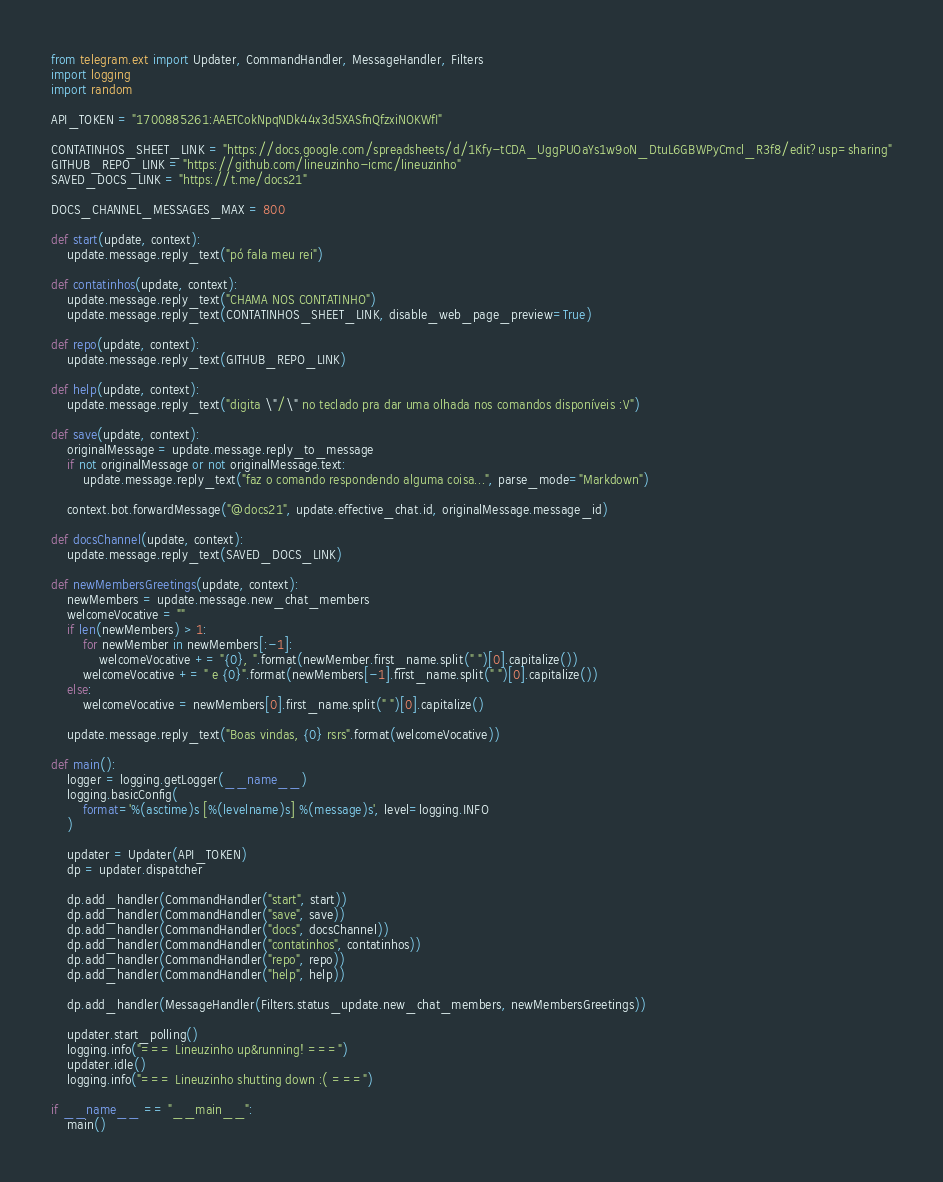<code> <loc_0><loc_0><loc_500><loc_500><_Python_>from telegram.ext import Updater, CommandHandler, MessageHandler, Filters
import logging
import random

API_TOKEN = "1700885261:AAETCokNpqNDk44x3d5XASfnQfzxiNOKWfI"

CONTATINHOS_SHEET_LINK = "https://docs.google.com/spreadsheets/d/1Kfy-tCDA_UggPUOaYs1w9oN_DtuL6GBWPyCmcl_R3f8/edit?usp=sharing"
GITHUB_REPO_LINK = "https://github.com/lineuzinho-icmc/lineuzinho"
SAVED_DOCS_LINK = "https://t.me/docs21"

DOCS_CHANNEL_MESSAGES_MAX = 800

def start(update, context):
    update.message.reply_text("pó fala meu rei")

def contatinhos(update, context):
    update.message.reply_text("CHAMA NOS CONTATINHO")
    update.message.reply_text(CONTATINHOS_SHEET_LINK, disable_web_page_preview=True)

def repo(update, context):
    update.message.reply_text(GITHUB_REPO_LINK)

def help(update, context):
    update.message.reply_text("digita \"/\" no teclado pra dar uma olhada nos comandos disponíveis :V")

def save(update, context):
    originalMessage = update.message.reply_to_message
    if not originalMessage or not originalMessage.text:
        update.message.reply_text("faz o comando respondendo alguma coisa...", parse_mode="Markdown")

    context.bot.forwardMessage("@docs21", update.effective_chat.id, originalMessage.message_id)

def docsChannel(update, context):
    update.message.reply_text(SAVED_DOCS_LINK)

def newMembersGreetings(update, context):
    newMembers = update.message.new_chat_members
    welcomeVocative = ""
    if len(newMembers) > 1:
        for newMember in newMembers[:-1]:
            welcomeVocative += "{0}, ".format(newMember.first_name.split(" ")[0].capitalize())
        welcomeVocative += " e {0}".format(newMembers[-1].first_name.split(" ")[0].capitalize())
    else:
        welcomeVocative = newMembers[0].first_name.split(" ")[0].capitalize()
    
    update.message.reply_text("Boas vindas, {0} rsrs".format(welcomeVocative))

def main():
    logger = logging.getLogger(__name__)
    logging.basicConfig(
        format='%(asctime)s [%(levelname)s] %(message)s', level=logging.INFO
    )

    updater = Updater(API_TOKEN)
    dp = updater.dispatcher

    dp.add_handler(CommandHandler("start", start))
    dp.add_handler(CommandHandler("save", save))
    dp.add_handler(CommandHandler("docs", docsChannel))
    dp.add_handler(CommandHandler("contatinhos", contatinhos))
    dp.add_handler(CommandHandler("repo", repo))
    dp.add_handler(CommandHandler("help", help))

    dp.add_handler(MessageHandler(Filters.status_update.new_chat_members, newMembersGreetings))

    updater.start_polling()
    logging.info("=== Lineuzinho up&running! ===")
    updater.idle()
    logging.info("=== Lineuzinho shutting down :( ===")

if __name__ == "__main__":
    main()</code> 